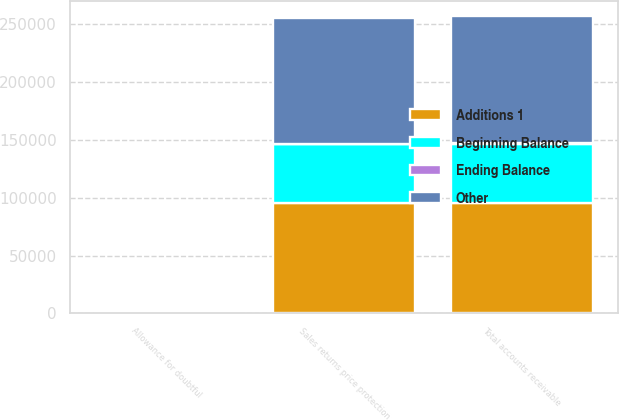Convert chart. <chart><loc_0><loc_0><loc_500><loc_500><stacked_bar_chart><ecel><fcel>Sales returns price protection<fcel>Total accounts receivable<fcel>Allowance for doubtful<nl><fcel>Beginning Balance<fcel>50290<fcel>51002<fcel>771<nl><fcel>Other<fcel>109107<fcel>109594<fcel>43<nl><fcel>Additions 1<fcel>95901<fcel>95901<fcel>32<nl><fcel>Ending Balance<fcel>616<fcel>614<fcel>14<nl></chart> 